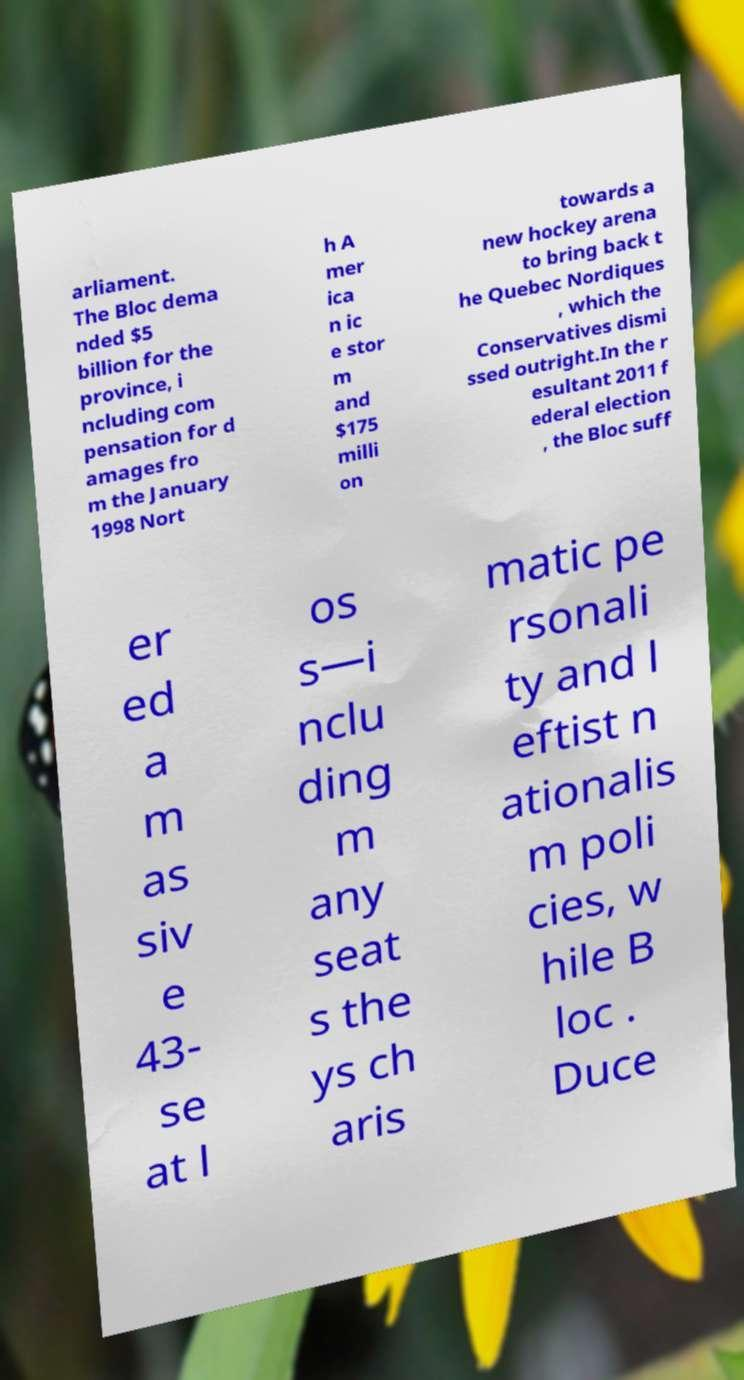Please identify and transcribe the text found in this image. arliament. The Bloc dema nded $5 billion for the province, i ncluding com pensation for d amages fro m the January 1998 Nort h A mer ica n ic e stor m and $175 milli on towards a new hockey arena to bring back t he Quebec Nordiques , which the Conservatives dismi ssed outright.In the r esultant 2011 f ederal election , the Bloc suff er ed a m as siv e 43- se at l os s—i nclu ding m any seat s the ys ch aris matic pe rsonali ty and l eftist n ationalis m poli cies, w hile B loc . Duce 